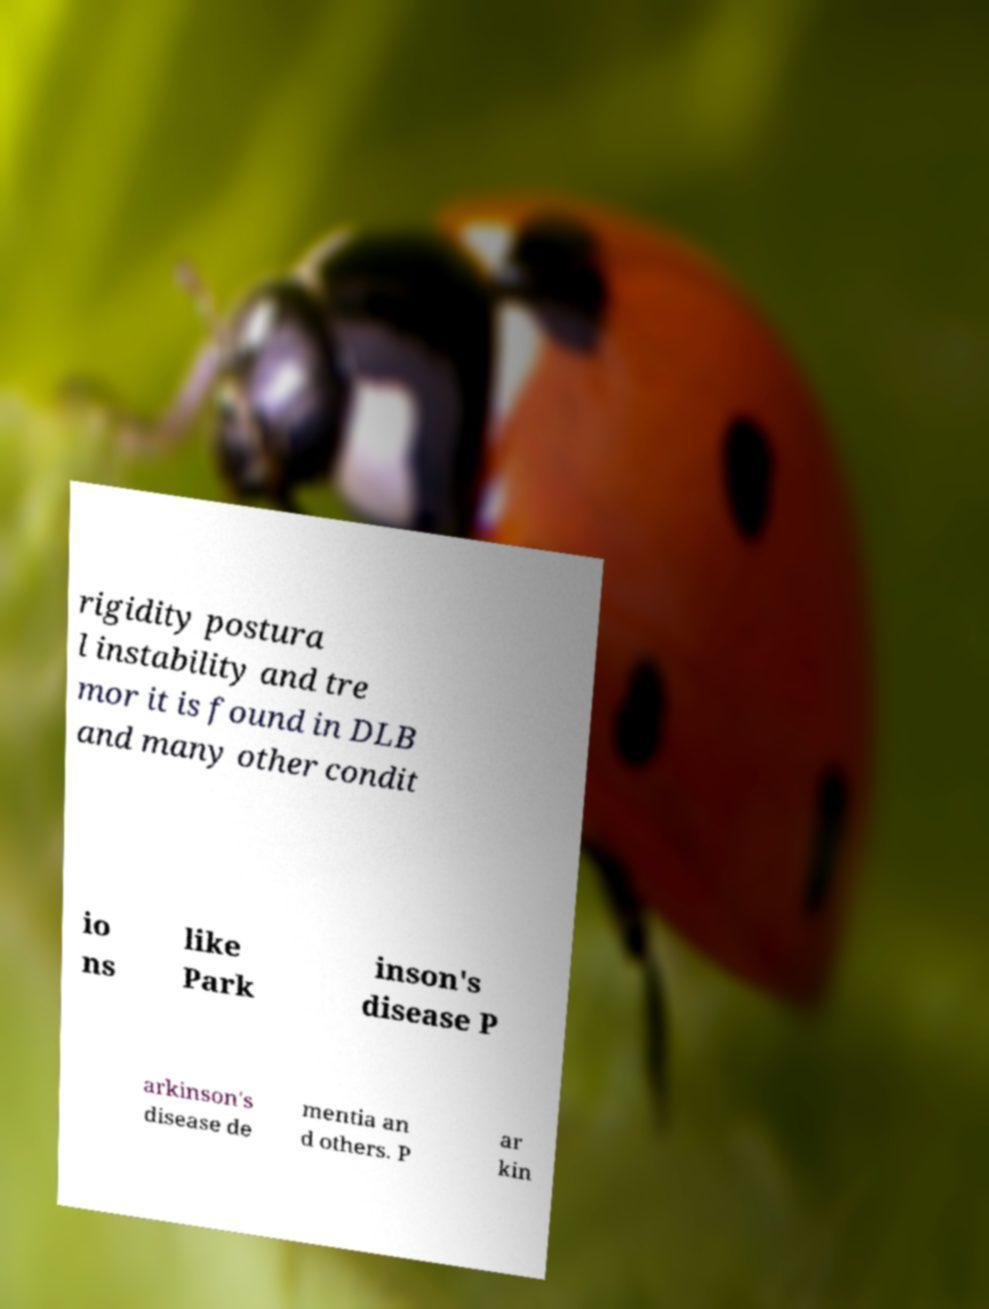Could you extract and type out the text from this image? rigidity postura l instability and tre mor it is found in DLB and many other condit io ns like Park inson's disease P arkinson's disease de mentia an d others. P ar kin 